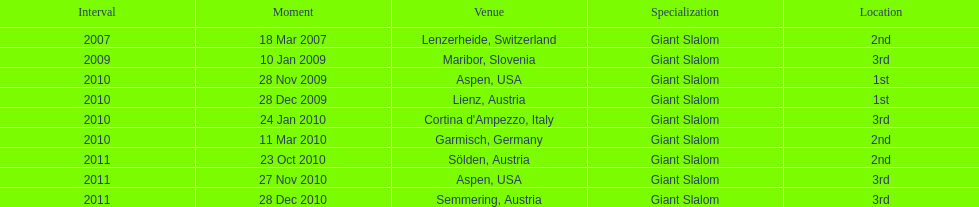The final race finishing place was not 1st but what other place? 3rd. 